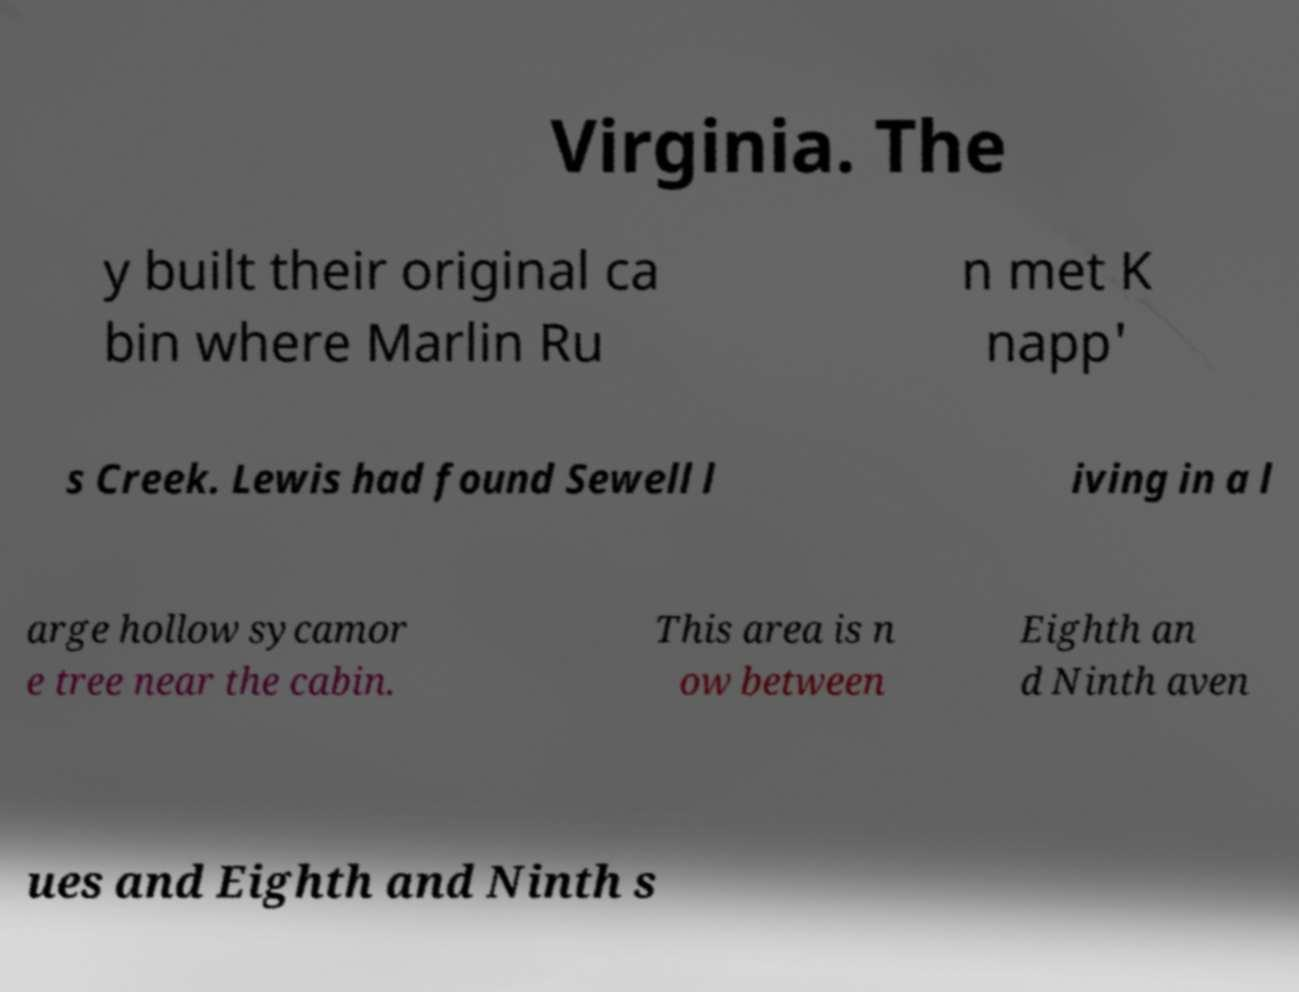There's text embedded in this image that I need extracted. Can you transcribe it verbatim? Virginia. The y built their original ca bin where Marlin Ru n met K napp' s Creek. Lewis had found Sewell l iving in a l arge hollow sycamor e tree near the cabin. This area is n ow between Eighth an d Ninth aven ues and Eighth and Ninth s 